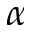Convert formula to latex. <formula><loc_0><loc_0><loc_500><loc_500>\alpha</formula> 